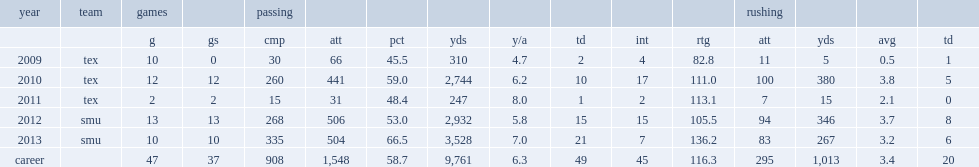How many yards did gilbert pass for in 2013? 3528.0. How many touchdowns did gilbert pass for in 2013? 21.0. 